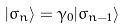<formula> <loc_0><loc_0><loc_500><loc_500>| \sigma _ { n } \rangle = \gamma _ { 0 } | \sigma _ { n - 1 } \rangle</formula> 